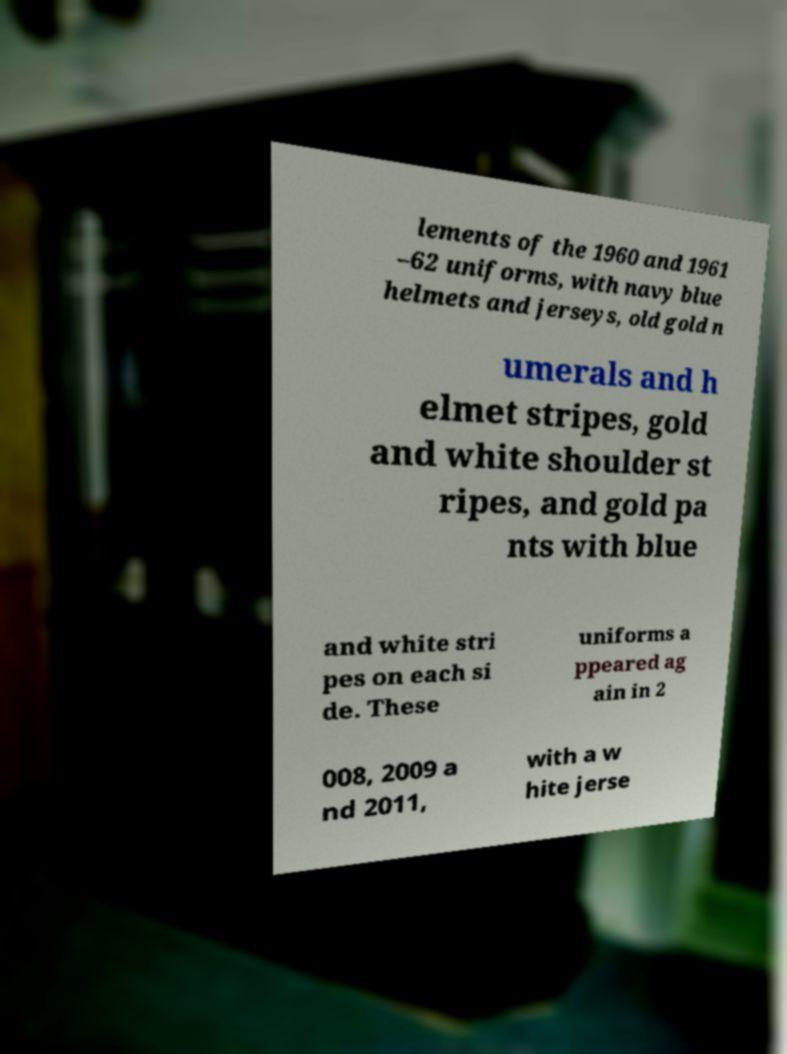For documentation purposes, I need the text within this image transcribed. Could you provide that? lements of the 1960 and 1961 –62 uniforms, with navy blue helmets and jerseys, old gold n umerals and h elmet stripes, gold and white shoulder st ripes, and gold pa nts with blue and white stri pes on each si de. These uniforms a ppeared ag ain in 2 008, 2009 a nd 2011, with a w hite jerse 